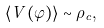<formula> <loc_0><loc_0><loc_500><loc_500>\langle V ( \varphi ) \rangle \sim \rho _ { c } ,</formula> 